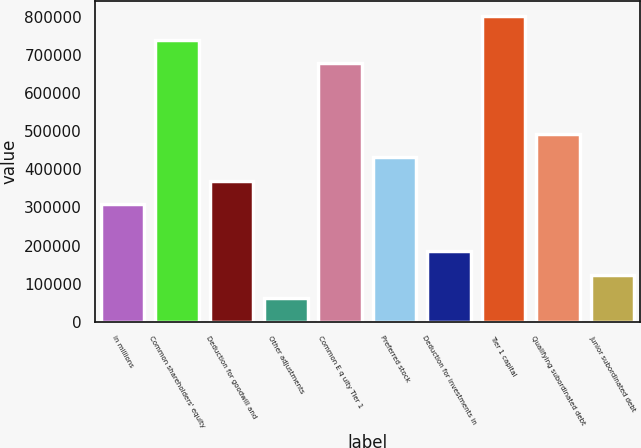Convert chart. <chart><loc_0><loc_0><loc_500><loc_500><bar_chart><fcel>in millions<fcel>Common shareholders' equity<fcel>Deduction for goodwill and<fcel>Other adjustments<fcel>Common E q uity Tier 1<fcel>Preferred stock<fcel>Deduction for investments in<fcel>Tier 1 capital<fcel>Qualifying subordinated debt<fcel>Junior subordinated debt<nl><fcel>308827<fcel>741174<fcel>370591<fcel>61772.2<fcel>679410<fcel>432355<fcel>185300<fcel>802937<fcel>494118<fcel>123536<nl></chart> 